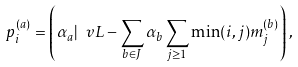Convert formula to latex. <formula><loc_0><loc_0><loc_500><loc_500>p _ { i } ^ { ( a ) } = \left ( \alpha _ { a } | \ v L - \sum _ { b \in J } \alpha _ { b } \sum _ { j \geq 1 } \min ( i , j ) m _ { j } ^ { ( b ) } \right ) ,</formula> 